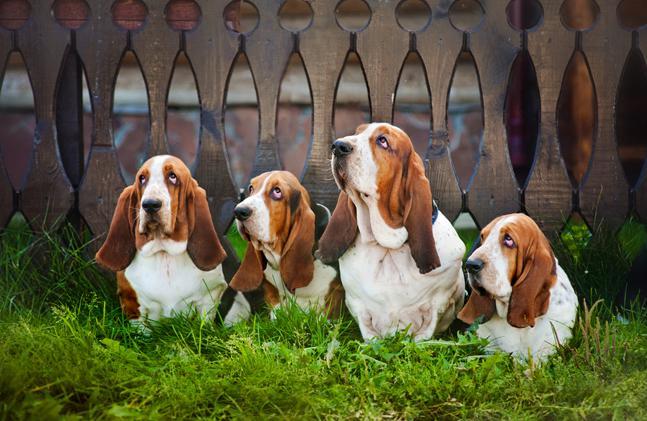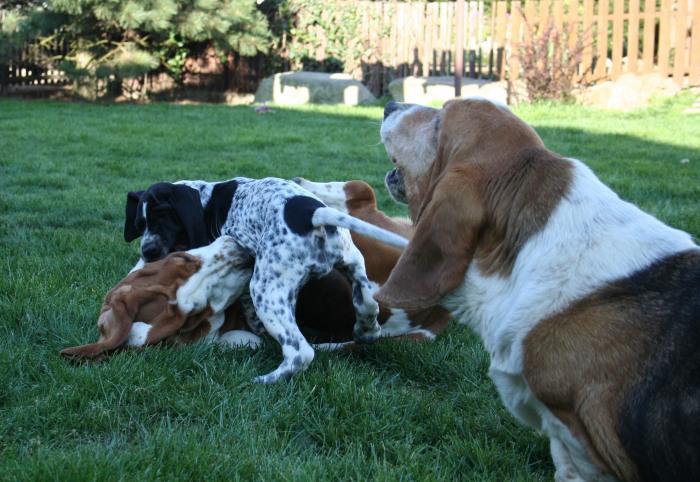The first image is the image on the left, the second image is the image on the right. Analyze the images presented: Is the assertion "There are four dogs outside in the image on the left." valid? Answer yes or no. Yes. 